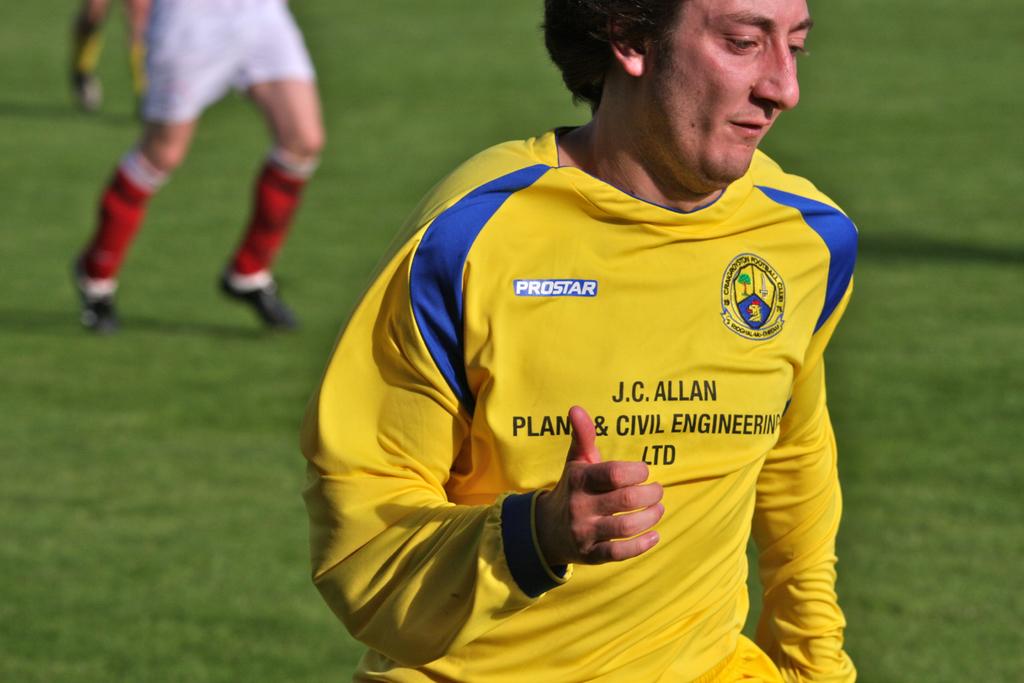What is the name of the company near the right shoulder of this player?
Give a very brief answer. Prostar. 